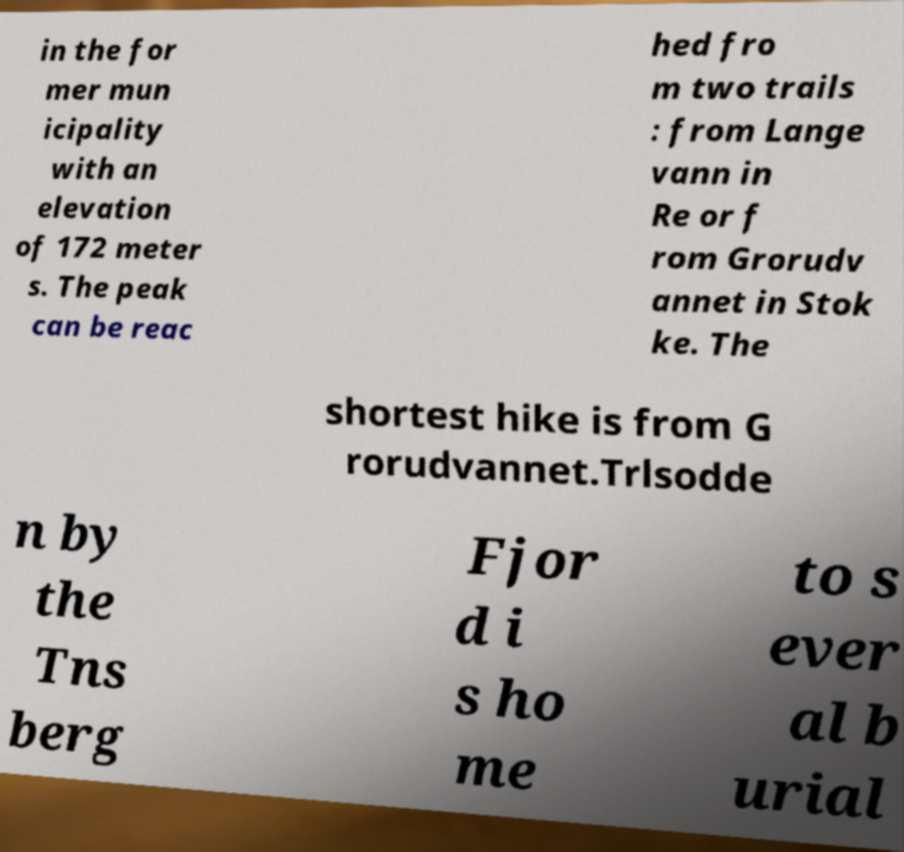I need the written content from this picture converted into text. Can you do that? in the for mer mun icipality with an elevation of 172 meter s. The peak can be reac hed fro m two trails : from Lange vann in Re or f rom Grorudv annet in Stok ke. The shortest hike is from G rorudvannet.Trlsodde n by the Tns berg Fjor d i s ho me to s ever al b urial 